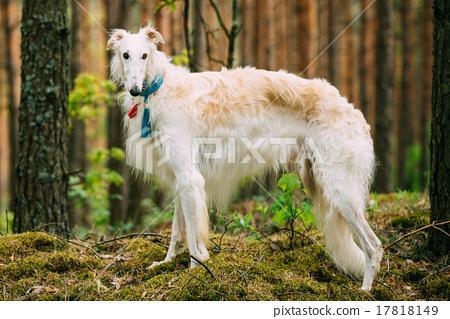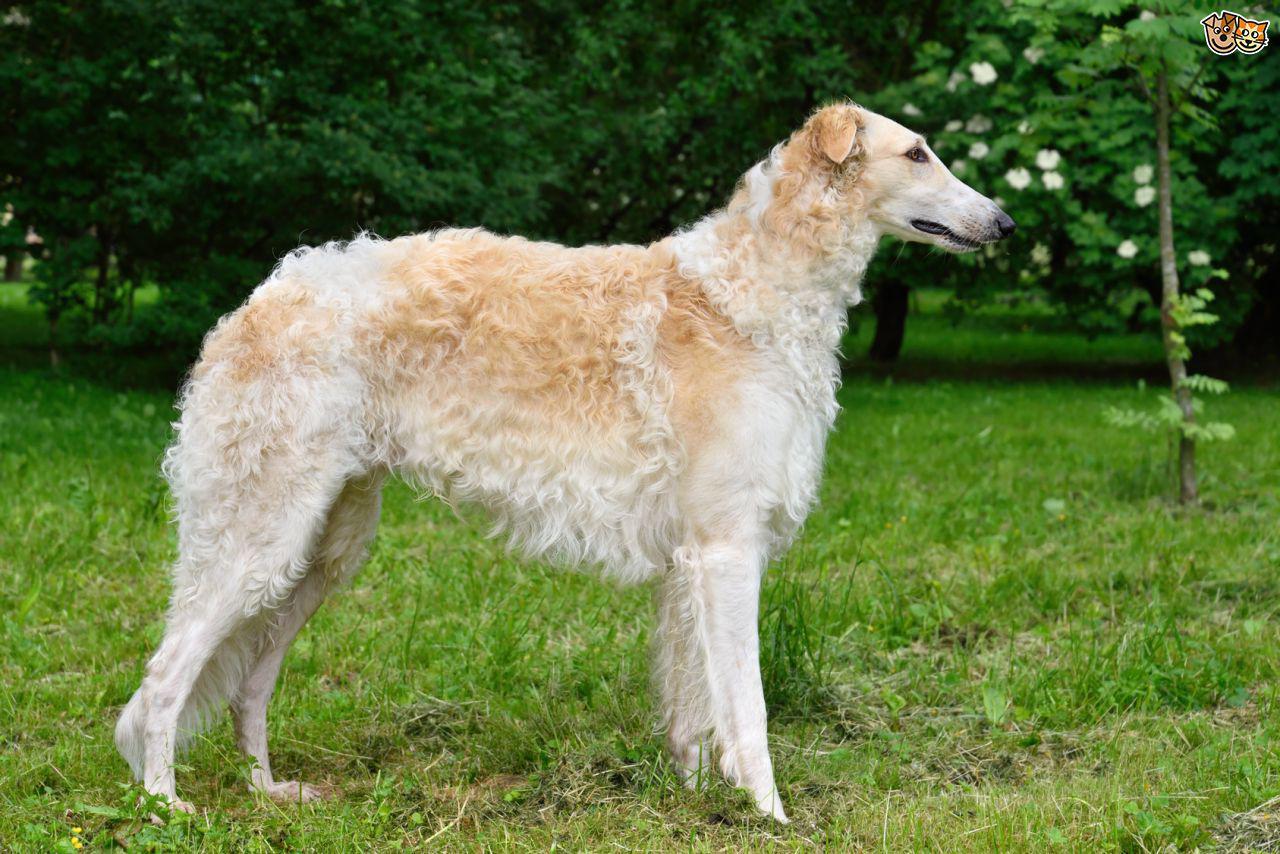The first image is the image on the left, the second image is the image on the right. Evaluate the accuracy of this statement regarding the images: "Each image contains exactly one hound, and the dogs in the left and right images share similar fur coloring and body poses.". Is it true? Answer yes or no. Yes. 